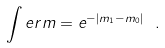Convert formula to latex. <formula><loc_0><loc_0><loc_500><loc_500>\int e r m = e ^ { - \left | m _ { 1 } - m _ { 0 } \right | } \ .</formula> 